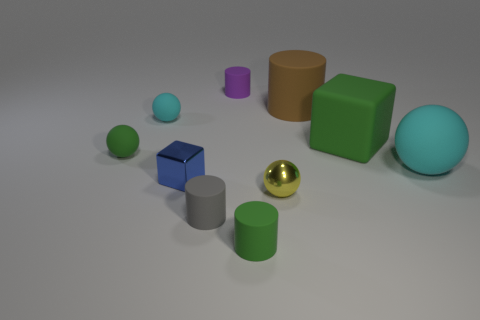What number of objects are large brown rubber blocks or small rubber balls that are on the right side of the tiny green ball?
Offer a very short reply. 1. There is a cyan rubber object on the right side of the large green matte block; does it have the same shape as the small gray matte object?
Give a very brief answer. No. How many small green matte things are behind the small green matte cylinder to the left of the ball that is in front of the big cyan object?
Make the answer very short. 1. How many things are either large cyan rubber objects or green rubber cubes?
Your answer should be very brief. 2. Is the shape of the blue thing the same as the matte thing that is behind the big brown matte cylinder?
Your answer should be compact. No. There is a small green object that is right of the tiny purple matte thing; what shape is it?
Ensure brevity in your answer.  Cylinder. Is the shape of the small gray object the same as the big cyan object?
Give a very brief answer. No. There is another metallic object that is the same shape as the small cyan object; what is its size?
Make the answer very short. Small. There is a cyan ball to the right of the brown rubber thing; is it the same size as the tiny cyan object?
Your answer should be very brief. No. What is the size of the rubber cylinder that is behind the gray object and to the left of the tiny green cylinder?
Give a very brief answer. Small. 